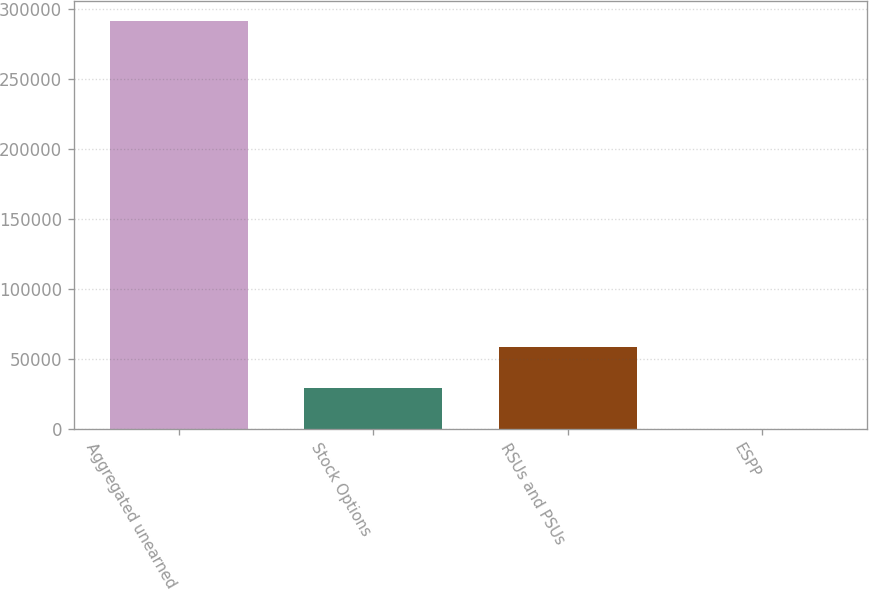<chart> <loc_0><loc_0><loc_500><loc_500><bar_chart><fcel>Aggregated unearned<fcel>Stock Options<fcel>RSUs and PSUs<fcel>ESPP<nl><fcel>291416<fcel>29142<fcel>58283.6<fcel>0.5<nl></chart> 